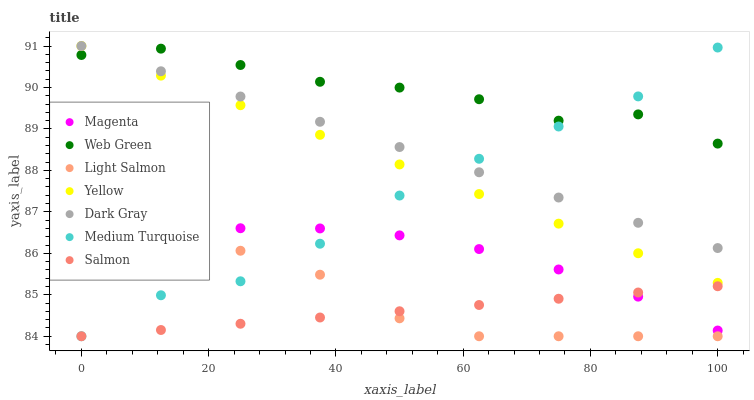Does Salmon have the minimum area under the curve?
Answer yes or no. Yes. Does Web Green have the maximum area under the curve?
Answer yes or no. Yes. Does Yellow have the minimum area under the curve?
Answer yes or no. No. Does Yellow have the maximum area under the curve?
Answer yes or no. No. Is Dark Gray the smoothest?
Answer yes or no. Yes. Is Web Green the roughest?
Answer yes or no. Yes. Is Salmon the smoothest?
Answer yes or no. No. Is Salmon the roughest?
Answer yes or no. No. Does Light Salmon have the lowest value?
Answer yes or no. Yes. Does Yellow have the lowest value?
Answer yes or no. No. Does Dark Gray have the highest value?
Answer yes or no. Yes. Does Salmon have the highest value?
Answer yes or no. No. Is Magenta less than Dark Gray?
Answer yes or no. Yes. Is Dark Gray greater than Salmon?
Answer yes or no. Yes. Does Magenta intersect Salmon?
Answer yes or no. Yes. Is Magenta less than Salmon?
Answer yes or no. No. Is Magenta greater than Salmon?
Answer yes or no. No. Does Magenta intersect Dark Gray?
Answer yes or no. No. 